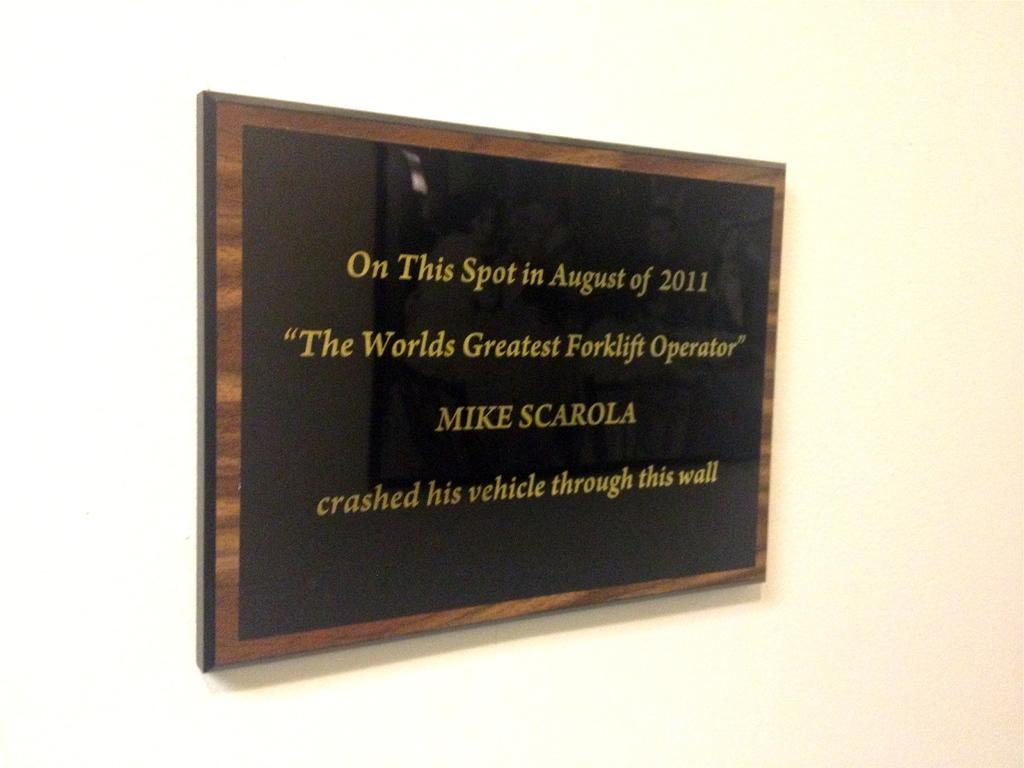<image>
Summarize the visual content of the image. A black and wood plaque hung on a way commemorating something that happened On this Spot in August of 2011. 